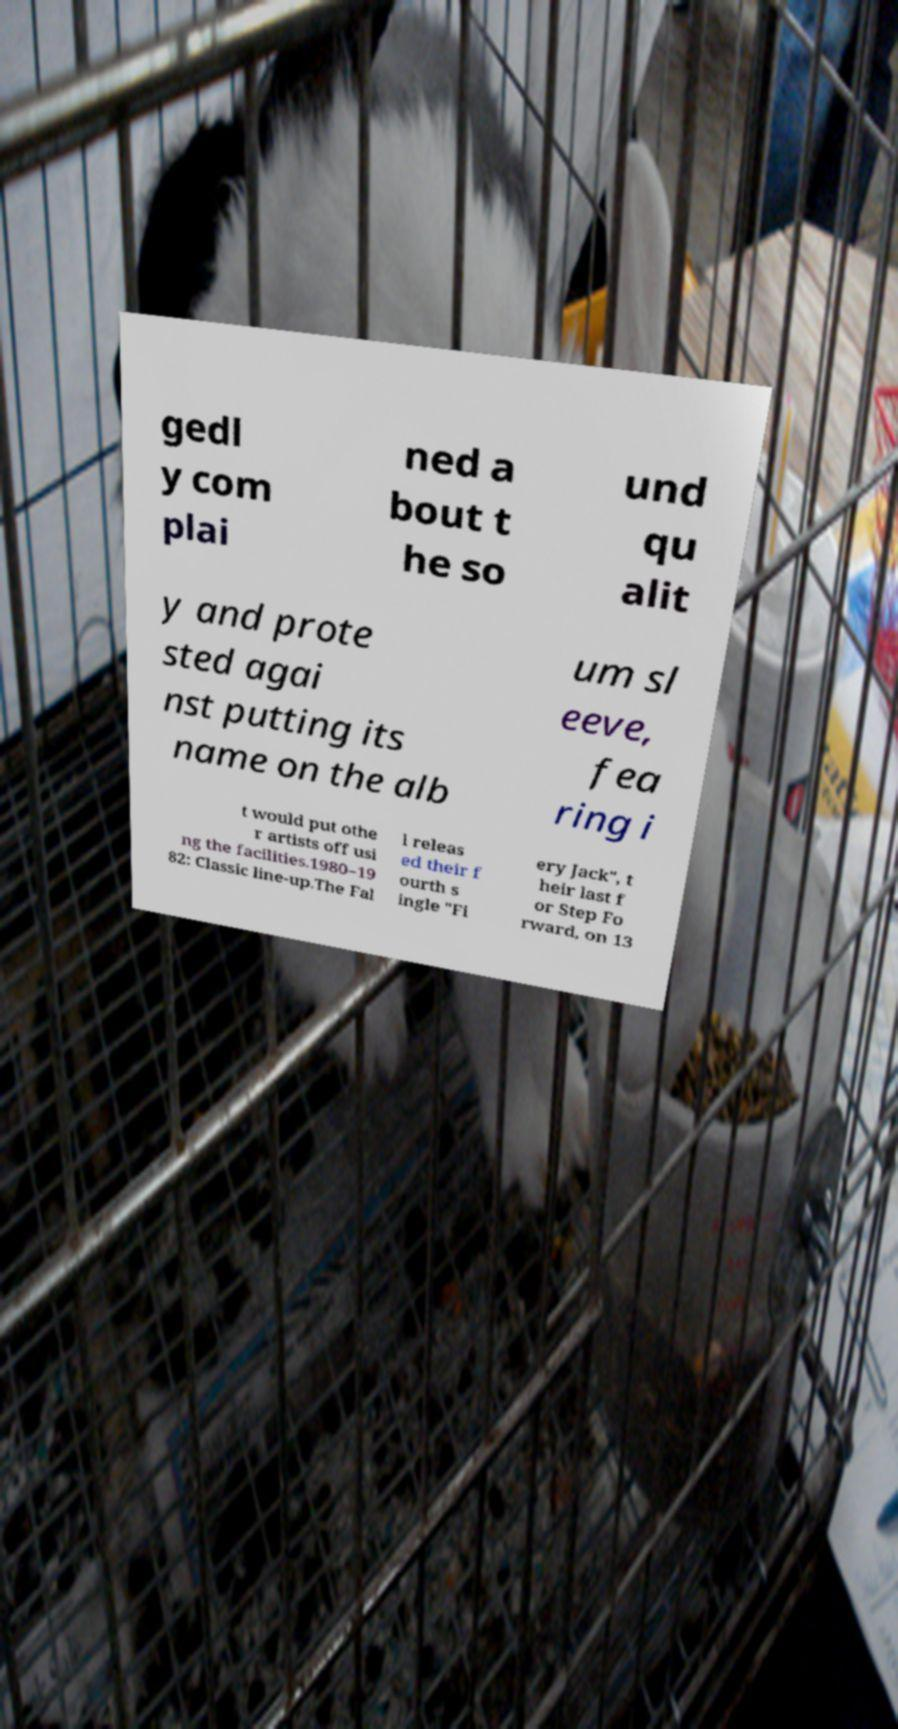Could you extract and type out the text from this image? gedl y com plai ned a bout t he so und qu alit y and prote sted agai nst putting its name on the alb um sl eeve, fea ring i t would put othe r artists off usi ng the facilities.1980–19 82: Classic line-up.The Fal l releas ed their f ourth s ingle "Fi ery Jack", t heir last f or Step Fo rward, on 13 